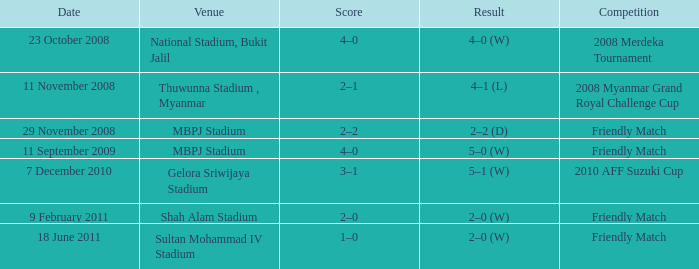What Competition in Shah Alam Stadium have a Result of 2–0 (w)? Friendly Match. 